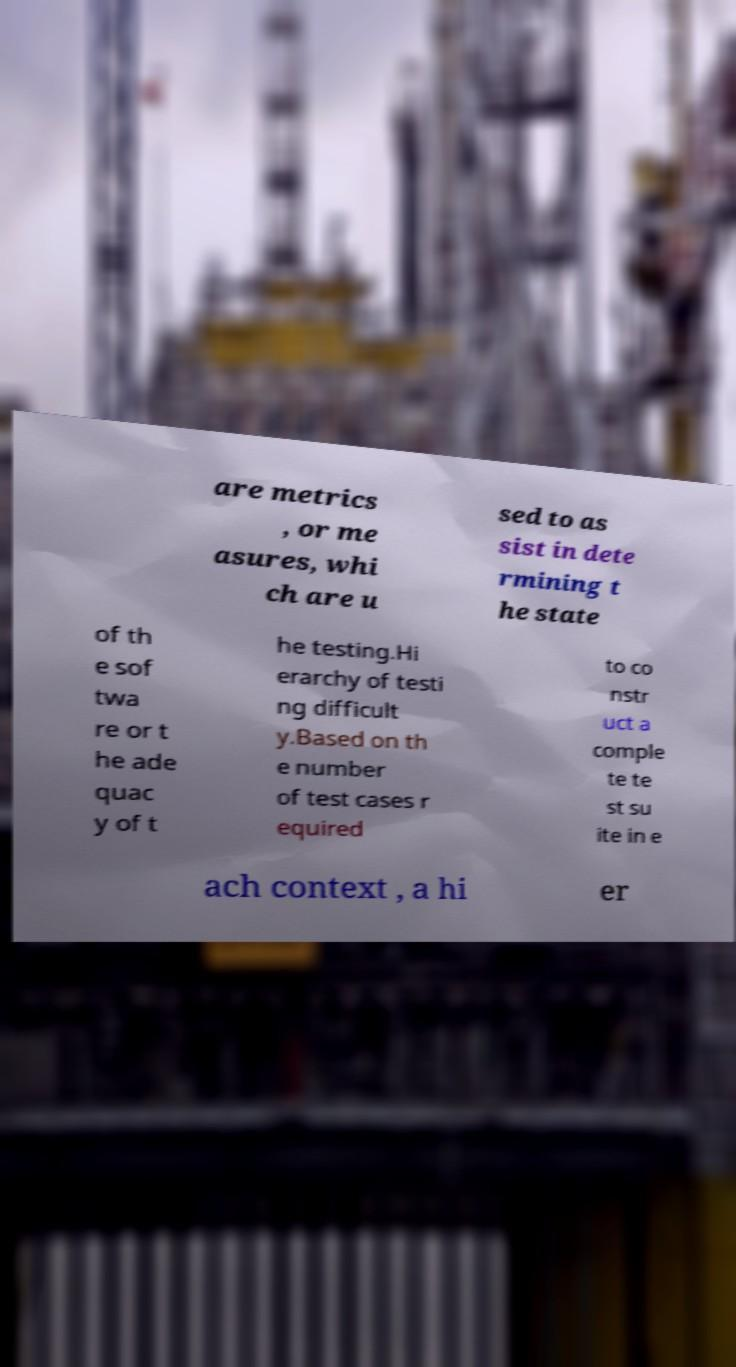What messages or text are displayed in this image? I need them in a readable, typed format. are metrics , or me asures, whi ch are u sed to as sist in dete rmining t he state of th e sof twa re or t he ade quac y of t he testing.Hi erarchy of testi ng difficult y.Based on th e number of test cases r equired to co nstr uct a comple te te st su ite in e ach context , a hi er 